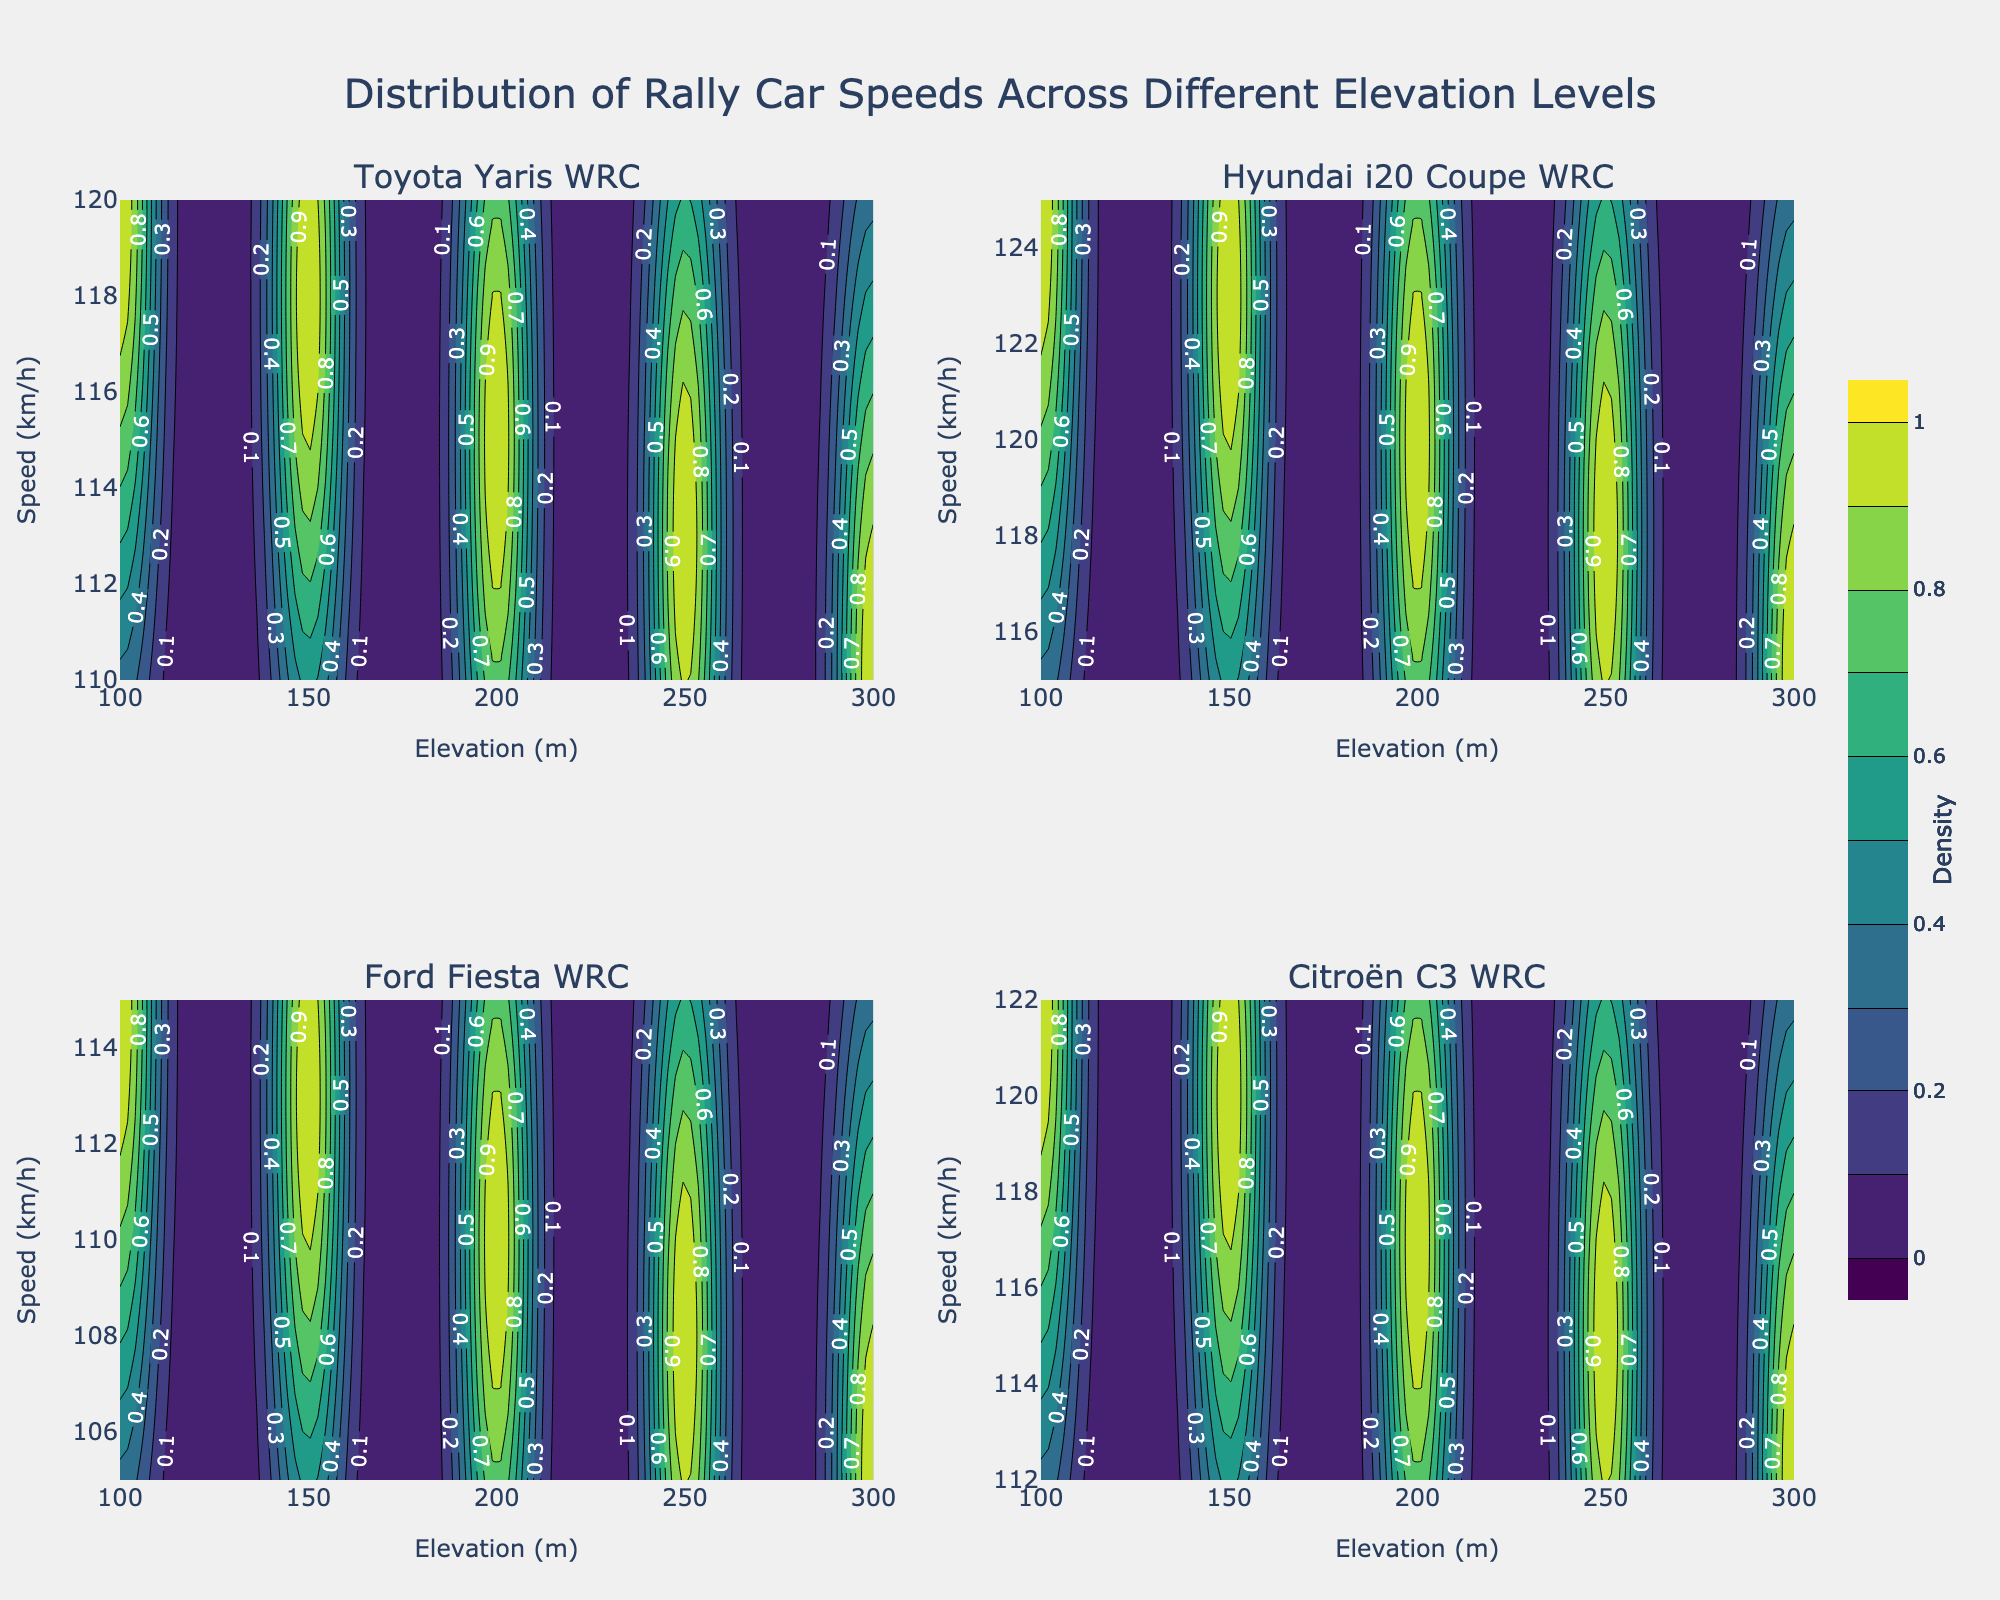What's the title of the figure? The title is usually displayed at the top center of the figure. Viewing the figure, you can see the title in a distinct font size and style, making it prominent.
Answer: Distribution of Rally Car Speeds Across Different Elevation Levels Which car model has the subplot located in the top right corner? The figure contains four subplots, each titled with a different car model. The top right corner corresponds to the second subplot position, whose title can be read.
Answer: Hyundai i20 Coupe WRC What are the axis labels for each subplot? The axis labels for the subplots can be seen on each x-axis and y-axis, respectively. Usually, these labels are positioned at the bottom and left side of each plot area.
Answer: Elevation (m) and Speed (km/h) Which car model's speeds decrease the fastest with increasing elevation? By comparing the contour plots of all four car models, one can identify which model has contour lines showing the steepest decline from top left to bottom right.
Answer: Ford Fiesta WRC How does the distribution of speeds for the Citroën C3 WRC compare with the Toyota Yaris WRC? To answer this, look at the shape and density of the contour lines in the respective subplots. Compare how spread out or concentrated the lines are to determine if the distribution is more uniform or varied.
Answer: Citroën C3 WRC has a less steep decline in speed with elevation compared to Toyota Yaris WRC Which car model has the highest speed at the lowest elevation? Identify the bottom-left corner of each subplot (lowest elevation) and check which car model's contour lines reach the highest speed value.
Answer: Hyundai i20 Coupe WRC At an elevation of 200m, which car model generally maintains the highest speed? Focus on the contour lines crossing the 200m mark on the elevation axis in each subplot and identify the highest speed value they intersect.
Answer: Hyundai i20 Coupe WRC Which contour plot shows the least variability in speeds across different elevations? Examine how tight or spread out the contour lines are in each subplot. The car model with the tightest contour lines shows the least variability in speed changes with elevation.
Answer: Citroën C3 WRC If you were to choose a car model for a rally track with varying elevation, which car's performance is the most consistent? Consistency here means minimal change in speeds across different elevations. Examine the subplots where contour lines are closest to being horizontal.
Answer: Citroën C3 WRC 